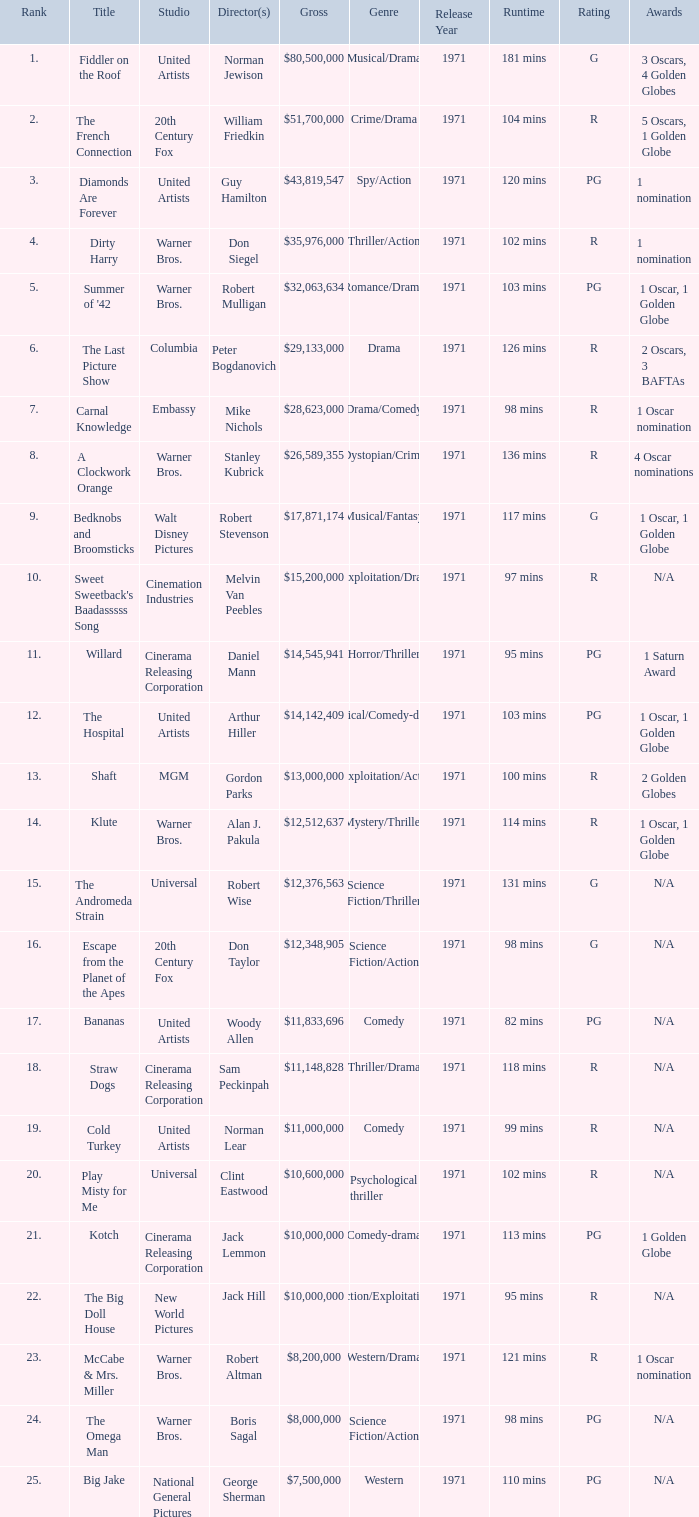Which title ranked lower than 19 has a gross of $11,833,696? Bananas. 